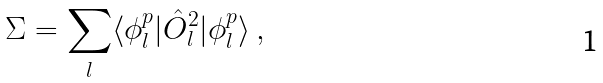<formula> <loc_0><loc_0><loc_500><loc_500>\Sigma = \sum _ { l } \langle { \phi } ^ { p } _ { l } | \hat { O } ^ { 2 } _ { l } | { \phi } ^ { p } _ { l } \rangle \, ,</formula> 